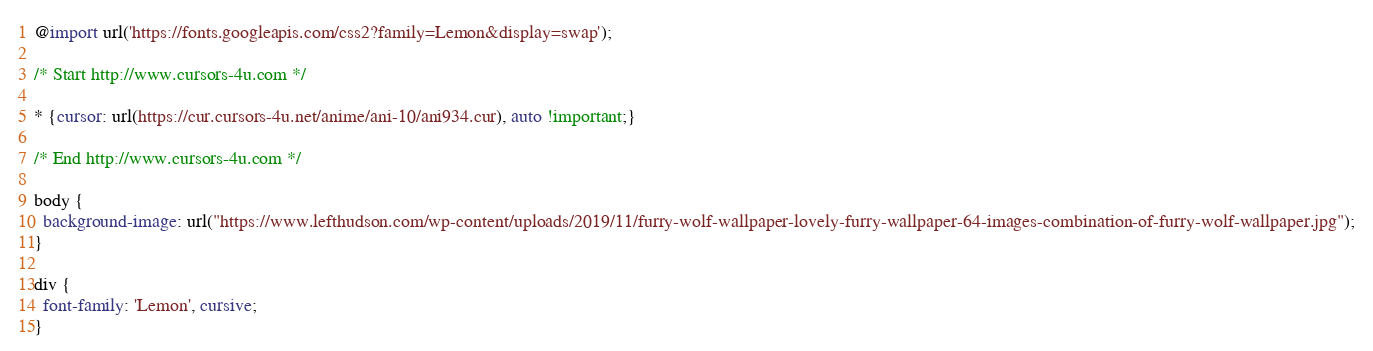Convert code to text. <code><loc_0><loc_0><loc_500><loc_500><_CSS_>@import url('https://fonts.googleapis.com/css2?family=Lemon&display=swap');

/* Start http://www.cursors-4u.com */

* {cursor: url(https://cur.cursors-4u.net/anime/ani-10/ani934.cur), auto !important;}

/* End http://www.cursors-4u.com */

body {
  background-image: url("https://www.lefthudson.com/wp-content/uploads/2019/11/furry-wolf-wallpaper-lovely-furry-wallpaper-64-images-combination-of-furry-wolf-wallpaper.jpg");
}

div {
  font-family: 'Lemon', cursive;
}</code> 